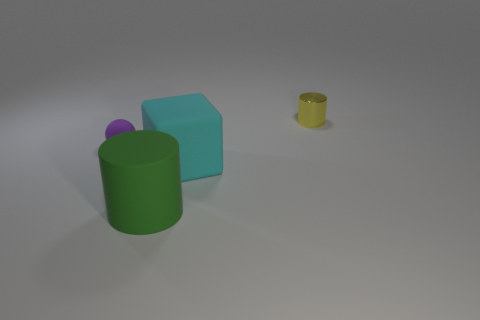Add 1 metal objects. How many objects exist? 5 Subtract 1 cylinders. How many cylinders are left? 1 Add 1 big cyan things. How many big cyan things are left? 2 Add 4 large yellow cubes. How many large yellow cubes exist? 4 Subtract 0 yellow cubes. How many objects are left? 4 Subtract all blocks. How many objects are left? 3 Subtract all cyan cylinders. Subtract all red balls. How many cylinders are left? 2 Subtract all blue cubes. How many green cylinders are left? 1 Subtract all green rubber things. Subtract all green rubber cylinders. How many objects are left? 2 